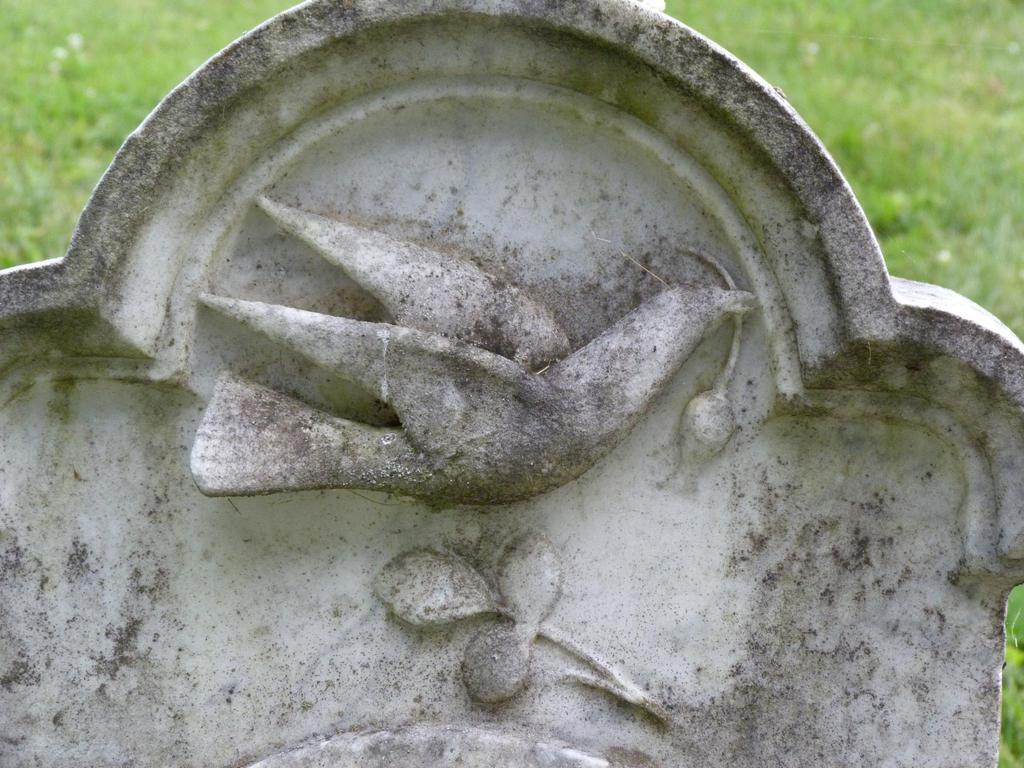What is the main subject of the image? There is a gravestone in the image. What is depicted on the gravestone? The gravestone has a sculpture of a bird. What is the bird sculpture holding in its mouth? The bird sculpture is holding a flower in its mouth. What type of surface is visible behind the gravestone? There is a grass surface behind the gravestone. What type of guitar can be seen in the image? There is no guitar present in the image. How does the bird sculpture express its love for the flower? The bird sculpture is not expressing love; it is simply holding a flower in its mouth. 